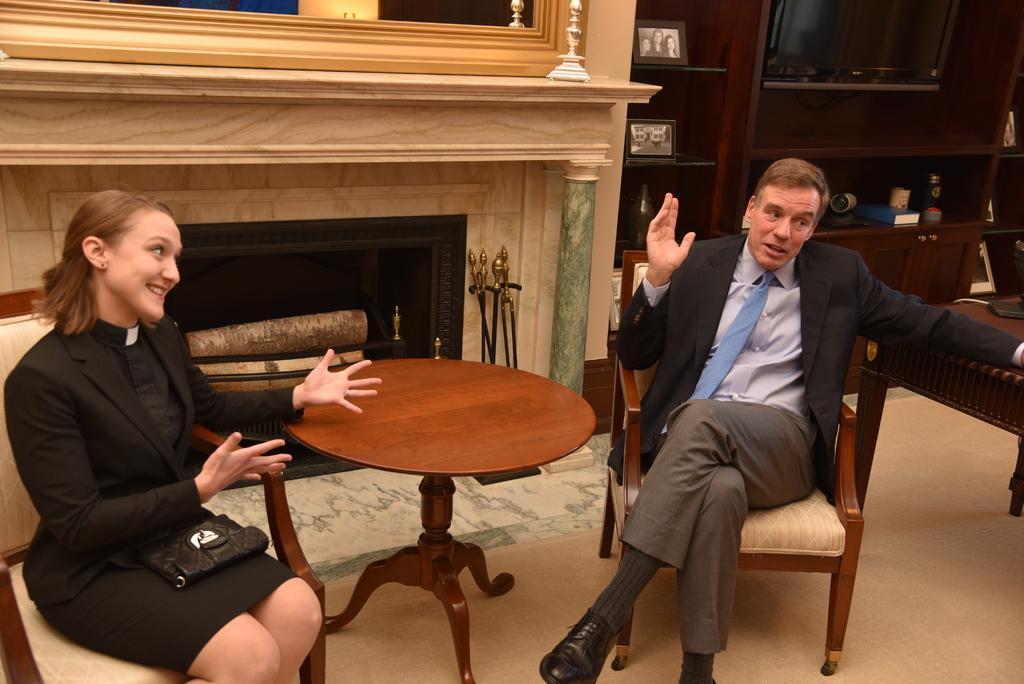Please provide a concise description of this image. This picture is clicked inside the room. On the right corner of this picture, we see a man with black blazer is sitting on the chair and talking something and the woman on the left corner of this picture wearing black blazer is also sitting on the chair and wearing a bag, black bag and she is laughing. In middle, there is a table and behind that, we see a wall and beside that, we see cupboard in which television, book, bottle, and photo frames are placed. 